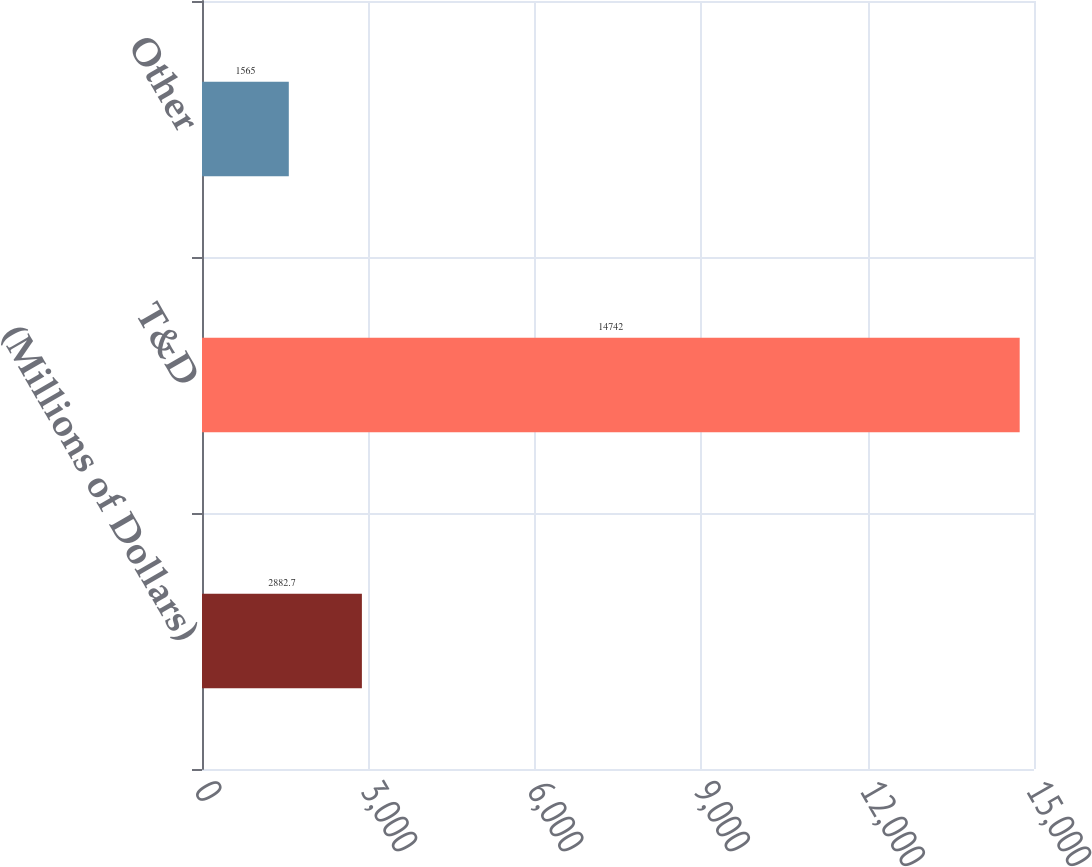Convert chart. <chart><loc_0><loc_0><loc_500><loc_500><bar_chart><fcel>(Millions of Dollars)<fcel>T&D<fcel>Other<nl><fcel>2882.7<fcel>14742<fcel>1565<nl></chart> 